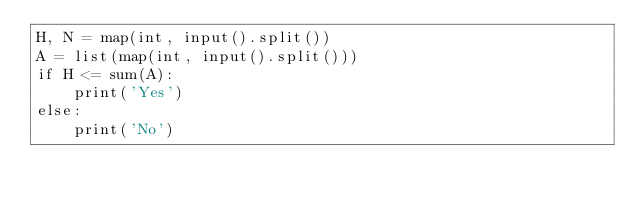Convert code to text. <code><loc_0><loc_0><loc_500><loc_500><_Python_>H, N = map(int, input().split())
A = list(map(int, input().split()))
if H <= sum(A):
    print('Yes')
else:
    print('No')
</code> 